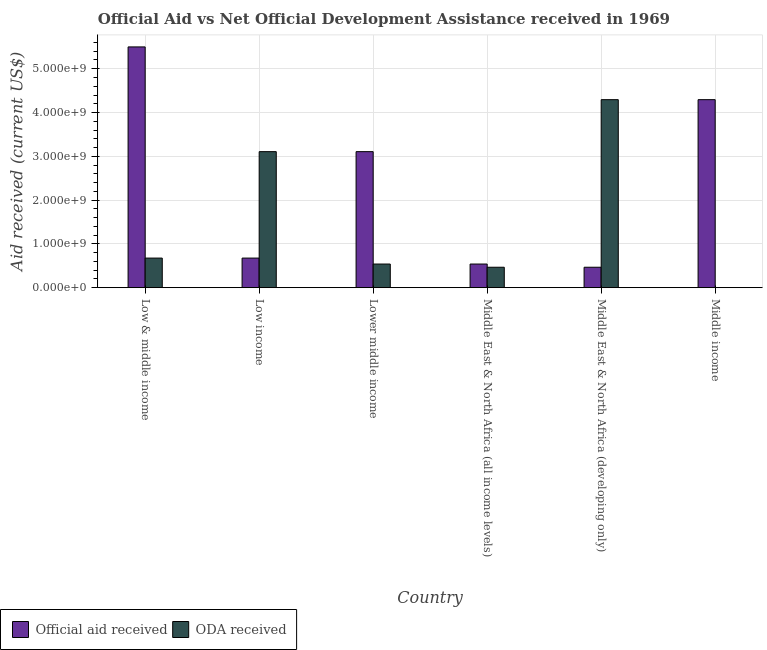In how many cases, is the number of bars for a given country not equal to the number of legend labels?
Ensure brevity in your answer.  0. What is the official aid received in Lower middle income?
Provide a succinct answer. 3.11e+09. Across all countries, what is the maximum oda received?
Your answer should be very brief. 4.29e+09. Across all countries, what is the minimum oda received?
Your answer should be compact. 10000. In which country was the official aid received maximum?
Provide a short and direct response. Low & middle income. In which country was the official aid received minimum?
Your answer should be very brief. Middle East & North Africa (developing only). What is the total official aid received in the graph?
Your answer should be compact. 1.46e+1. What is the difference between the oda received in Low income and that in Middle income?
Give a very brief answer. 3.11e+09. What is the difference between the official aid received in Low income and the oda received in Middle East & North Africa (all income levels)?
Keep it short and to the point. 2.09e+08. What is the average oda received per country?
Offer a terse response. 1.51e+09. What is the difference between the oda received and official aid received in Low & middle income?
Provide a succinct answer. -4.82e+09. What is the ratio of the official aid received in Low & middle income to that in Middle East & North Africa (developing only)?
Give a very brief answer. 11.79. Is the difference between the official aid received in Low income and Middle East & North Africa (developing only) greater than the difference between the oda received in Low income and Middle East & North Africa (developing only)?
Give a very brief answer. Yes. What is the difference between the highest and the second highest official aid received?
Give a very brief answer. 1.20e+09. What is the difference between the highest and the lowest official aid received?
Offer a very short reply. 5.03e+09. Is the sum of the official aid received in Low & middle income and Middle East & North Africa (developing only) greater than the maximum oda received across all countries?
Give a very brief answer. Yes. What does the 2nd bar from the left in Low income represents?
Your response must be concise. ODA received. What does the 2nd bar from the right in Low & middle income represents?
Your answer should be compact. Official aid received. Are all the bars in the graph horizontal?
Ensure brevity in your answer.  No. How many countries are there in the graph?
Keep it short and to the point. 6. What is the difference between two consecutive major ticks on the Y-axis?
Give a very brief answer. 1.00e+09. Does the graph contain any zero values?
Your response must be concise. No. Does the graph contain grids?
Offer a terse response. Yes. How many legend labels are there?
Give a very brief answer. 2. What is the title of the graph?
Offer a very short reply. Official Aid vs Net Official Development Assistance received in 1969 . What is the label or title of the X-axis?
Offer a very short reply. Country. What is the label or title of the Y-axis?
Keep it short and to the point. Aid received (current US$). What is the Aid received (current US$) of Official aid received in Low & middle income?
Offer a terse response. 5.50e+09. What is the Aid received (current US$) in ODA received in Low & middle income?
Provide a short and direct response. 6.76e+08. What is the Aid received (current US$) of Official aid received in Low income?
Give a very brief answer. 6.76e+08. What is the Aid received (current US$) of ODA received in Low income?
Offer a very short reply. 3.11e+09. What is the Aid received (current US$) of Official aid received in Lower middle income?
Your answer should be compact. 3.11e+09. What is the Aid received (current US$) of ODA received in Lower middle income?
Give a very brief answer. 5.39e+08. What is the Aid received (current US$) in Official aid received in Middle East & North Africa (all income levels)?
Your answer should be very brief. 5.39e+08. What is the Aid received (current US$) of ODA received in Middle East & North Africa (all income levels)?
Give a very brief answer. 4.66e+08. What is the Aid received (current US$) of Official aid received in Middle East & North Africa (developing only)?
Your answer should be very brief. 4.66e+08. What is the Aid received (current US$) of ODA received in Middle East & North Africa (developing only)?
Offer a very short reply. 4.29e+09. What is the Aid received (current US$) in Official aid received in Middle income?
Your response must be concise. 4.29e+09. What is the Aid received (current US$) of ODA received in Middle income?
Provide a short and direct response. 10000. Across all countries, what is the maximum Aid received (current US$) of Official aid received?
Keep it short and to the point. 5.50e+09. Across all countries, what is the maximum Aid received (current US$) in ODA received?
Provide a short and direct response. 4.29e+09. Across all countries, what is the minimum Aid received (current US$) of Official aid received?
Provide a succinct answer. 4.66e+08. Across all countries, what is the minimum Aid received (current US$) in ODA received?
Ensure brevity in your answer.  10000. What is the total Aid received (current US$) in Official aid received in the graph?
Keep it short and to the point. 1.46e+1. What is the total Aid received (current US$) of ODA received in the graph?
Your answer should be compact. 9.08e+09. What is the difference between the Aid received (current US$) of Official aid received in Low & middle income and that in Low income?
Your answer should be compact. 4.82e+09. What is the difference between the Aid received (current US$) in ODA received in Low & middle income and that in Low income?
Provide a succinct answer. -2.43e+09. What is the difference between the Aid received (current US$) in Official aid received in Low & middle income and that in Lower middle income?
Make the answer very short. 2.39e+09. What is the difference between the Aid received (current US$) in ODA received in Low & middle income and that in Lower middle income?
Your answer should be compact. 1.36e+08. What is the difference between the Aid received (current US$) in Official aid received in Low & middle income and that in Middle East & North Africa (all income levels)?
Your answer should be compact. 4.96e+09. What is the difference between the Aid received (current US$) of ODA received in Low & middle income and that in Middle East & North Africa (all income levels)?
Keep it short and to the point. 2.09e+08. What is the difference between the Aid received (current US$) of Official aid received in Low & middle income and that in Middle East & North Africa (developing only)?
Your response must be concise. 5.03e+09. What is the difference between the Aid received (current US$) in ODA received in Low & middle income and that in Middle East & North Africa (developing only)?
Your answer should be compact. -3.62e+09. What is the difference between the Aid received (current US$) in Official aid received in Low & middle income and that in Middle income?
Your answer should be compact. 1.20e+09. What is the difference between the Aid received (current US$) of ODA received in Low & middle income and that in Middle income?
Offer a terse response. 6.76e+08. What is the difference between the Aid received (current US$) of Official aid received in Low income and that in Lower middle income?
Make the answer very short. -2.43e+09. What is the difference between the Aid received (current US$) in ODA received in Low income and that in Lower middle income?
Make the answer very short. 2.57e+09. What is the difference between the Aid received (current US$) in Official aid received in Low income and that in Middle East & North Africa (all income levels)?
Ensure brevity in your answer.  1.36e+08. What is the difference between the Aid received (current US$) in ODA received in Low income and that in Middle East & North Africa (all income levels)?
Provide a succinct answer. 2.64e+09. What is the difference between the Aid received (current US$) in Official aid received in Low income and that in Middle East & North Africa (developing only)?
Your answer should be very brief. 2.09e+08. What is the difference between the Aid received (current US$) of ODA received in Low income and that in Middle East & North Africa (developing only)?
Give a very brief answer. -1.19e+09. What is the difference between the Aid received (current US$) of Official aid received in Low income and that in Middle income?
Your answer should be compact. -3.62e+09. What is the difference between the Aid received (current US$) of ODA received in Low income and that in Middle income?
Offer a terse response. 3.11e+09. What is the difference between the Aid received (current US$) of Official aid received in Lower middle income and that in Middle East & North Africa (all income levels)?
Provide a short and direct response. 2.57e+09. What is the difference between the Aid received (current US$) in ODA received in Lower middle income and that in Middle East & North Africa (all income levels)?
Make the answer very short. 7.30e+07. What is the difference between the Aid received (current US$) in Official aid received in Lower middle income and that in Middle East & North Africa (developing only)?
Offer a very short reply. 2.64e+09. What is the difference between the Aid received (current US$) in ODA received in Lower middle income and that in Middle East & North Africa (developing only)?
Make the answer very short. -3.75e+09. What is the difference between the Aid received (current US$) in Official aid received in Lower middle income and that in Middle income?
Provide a succinct answer. -1.19e+09. What is the difference between the Aid received (current US$) in ODA received in Lower middle income and that in Middle income?
Your answer should be very brief. 5.39e+08. What is the difference between the Aid received (current US$) in Official aid received in Middle East & North Africa (all income levels) and that in Middle East & North Africa (developing only)?
Offer a terse response. 7.30e+07. What is the difference between the Aid received (current US$) in ODA received in Middle East & North Africa (all income levels) and that in Middle East & North Africa (developing only)?
Keep it short and to the point. -3.83e+09. What is the difference between the Aid received (current US$) in Official aid received in Middle East & North Africa (all income levels) and that in Middle income?
Offer a terse response. -3.75e+09. What is the difference between the Aid received (current US$) of ODA received in Middle East & North Africa (all income levels) and that in Middle income?
Provide a short and direct response. 4.66e+08. What is the difference between the Aid received (current US$) of Official aid received in Middle East & North Africa (developing only) and that in Middle income?
Offer a very short reply. -3.83e+09. What is the difference between the Aid received (current US$) of ODA received in Middle East & North Africa (developing only) and that in Middle income?
Ensure brevity in your answer.  4.29e+09. What is the difference between the Aid received (current US$) of Official aid received in Low & middle income and the Aid received (current US$) of ODA received in Low income?
Ensure brevity in your answer.  2.39e+09. What is the difference between the Aid received (current US$) of Official aid received in Low & middle income and the Aid received (current US$) of ODA received in Lower middle income?
Offer a very short reply. 4.96e+09. What is the difference between the Aid received (current US$) in Official aid received in Low & middle income and the Aid received (current US$) in ODA received in Middle East & North Africa (all income levels)?
Give a very brief answer. 5.03e+09. What is the difference between the Aid received (current US$) in Official aid received in Low & middle income and the Aid received (current US$) in ODA received in Middle East & North Africa (developing only)?
Your answer should be very brief. 1.20e+09. What is the difference between the Aid received (current US$) in Official aid received in Low & middle income and the Aid received (current US$) in ODA received in Middle income?
Offer a terse response. 5.50e+09. What is the difference between the Aid received (current US$) in Official aid received in Low income and the Aid received (current US$) in ODA received in Lower middle income?
Your answer should be very brief. 1.36e+08. What is the difference between the Aid received (current US$) in Official aid received in Low income and the Aid received (current US$) in ODA received in Middle East & North Africa (all income levels)?
Your answer should be very brief. 2.09e+08. What is the difference between the Aid received (current US$) of Official aid received in Low income and the Aid received (current US$) of ODA received in Middle East & North Africa (developing only)?
Ensure brevity in your answer.  -3.62e+09. What is the difference between the Aid received (current US$) in Official aid received in Low income and the Aid received (current US$) in ODA received in Middle income?
Provide a succinct answer. 6.76e+08. What is the difference between the Aid received (current US$) in Official aid received in Lower middle income and the Aid received (current US$) in ODA received in Middle East & North Africa (all income levels)?
Provide a succinct answer. 2.64e+09. What is the difference between the Aid received (current US$) of Official aid received in Lower middle income and the Aid received (current US$) of ODA received in Middle East & North Africa (developing only)?
Keep it short and to the point. -1.19e+09. What is the difference between the Aid received (current US$) of Official aid received in Lower middle income and the Aid received (current US$) of ODA received in Middle income?
Offer a terse response. 3.11e+09. What is the difference between the Aid received (current US$) of Official aid received in Middle East & North Africa (all income levels) and the Aid received (current US$) of ODA received in Middle East & North Africa (developing only)?
Offer a very short reply. -3.75e+09. What is the difference between the Aid received (current US$) of Official aid received in Middle East & North Africa (all income levels) and the Aid received (current US$) of ODA received in Middle income?
Provide a succinct answer. 5.39e+08. What is the difference between the Aid received (current US$) in Official aid received in Middle East & North Africa (developing only) and the Aid received (current US$) in ODA received in Middle income?
Offer a terse response. 4.66e+08. What is the average Aid received (current US$) of Official aid received per country?
Your response must be concise. 2.43e+09. What is the average Aid received (current US$) of ODA received per country?
Make the answer very short. 1.51e+09. What is the difference between the Aid received (current US$) of Official aid received and Aid received (current US$) of ODA received in Low & middle income?
Provide a short and direct response. 4.82e+09. What is the difference between the Aid received (current US$) of Official aid received and Aid received (current US$) of ODA received in Low income?
Keep it short and to the point. -2.43e+09. What is the difference between the Aid received (current US$) of Official aid received and Aid received (current US$) of ODA received in Lower middle income?
Provide a succinct answer. 2.57e+09. What is the difference between the Aid received (current US$) in Official aid received and Aid received (current US$) in ODA received in Middle East & North Africa (all income levels)?
Provide a succinct answer. 7.30e+07. What is the difference between the Aid received (current US$) in Official aid received and Aid received (current US$) in ODA received in Middle East & North Africa (developing only)?
Offer a terse response. -3.83e+09. What is the difference between the Aid received (current US$) in Official aid received and Aid received (current US$) in ODA received in Middle income?
Ensure brevity in your answer.  4.29e+09. What is the ratio of the Aid received (current US$) of Official aid received in Low & middle income to that in Low income?
Provide a succinct answer. 8.14. What is the ratio of the Aid received (current US$) in ODA received in Low & middle income to that in Low income?
Your response must be concise. 0.22. What is the ratio of the Aid received (current US$) in Official aid received in Low & middle income to that in Lower middle income?
Your response must be concise. 1.77. What is the ratio of the Aid received (current US$) of ODA received in Low & middle income to that in Lower middle income?
Offer a terse response. 1.25. What is the ratio of the Aid received (current US$) of Official aid received in Low & middle income to that in Middle East & North Africa (all income levels)?
Provide a succinct answer. 10.19. What is the ratio of the Aid received (current US$) of ODA received in Low & middle income to that in Middle East & North Africa (all income levels)?
Ensure brevity in your answer.  1.45. What is the ratio of the Aid received (current US$) of Official aid received in Low & middle income to that in Middle East & North Africa (developing only)?
Your answer should be compact. 11.79. What is the ratio of the Aid received (current US$) in ODA received in Low & middle income to that in Middle East & North Africa (developing only)?
Provide a short and direct response. 0.16. What is the ratio of the Aid received (current US$) in Official aid received in Low & middle income to that in Middle income?
Your answer should be compact. 1.28. What is the ratio of the Aid received (current US$) in ODA received in Low & middle income to that in Middle income?
Your response must be concise. 6.76e+04. What is the ratio of the Aid received (current US$) of Official aid received in Low income to that in Lower middle income?
Provide a short and direct response. 0.22. What is the ratio of the Aid received (current US$) in ODA received in Low income to that in Lower middle income?
Provide a short and direct response. 5.76. What is the ratio of the Aid received (current US$) in Official aid received in Low income to that in Middle East & North Africa (all income levels)?
Offer a very short reply. 1.25. What is the ratio of the Aid received (current US$) of ODA received in Low income to that in Middle East & North Africa (all income levels)?
Ensure brevity in your answer.  6.66. What is the ratio of the Aid received (current US$) of Official aid received in Low income to that in Middle East & North Africa (developing only)?
Offer a very short reply. 1.45. What is the ratio of the Aid received (current US$) of ODA received in Low income to that in Middle East & North Africa (developing only)?
Make the answer very short. 0.72. What is the ratio of the Aid received (current US$) in Official aid received in Low income to that in Middle income?
Make the answer very short. 0.16. What is the ratio of the Aid received (current US$) in ODA received in Low income to that in Middle income?
Provide a succinct answer. 3.11e+05. What is the ratio of the Aid received (current US$) of Official aid received in Lower middle income to that in Middle East & North Africa (all income levels)?
Offer a terse response. 5.76. What is the ratio of the Aid received (current US$) in ODA received in Lower middle income to that in Middle East & North Africa (all income levels)?
Your response must be concise. 1.16. What is the ratio of the Aid received (current US$) of Official aid received in Lower middle income to that in Middle East & North Africa (developing only)?
Offer a very short reply. 6.66. What is the ratio of the Aid received (current US$) of ODA received in Lower middle income to that in Middle East & North Africa (developing only)?
Provide a short and direct response. 0.13. What is the ratio of the Aid received (current US$) in Official aid received in Lower middle income to that in Middle income?
Your answer should be compact. 0.72. What is the ratio of the Aid received (current US$) in ODA received in Lower middle income to that in Middle income?
Your answer should be compact. 5.39e+04. What is the ratio of the Aid received (current US$) of Official aid received in Middle East & North Africa (all income levels) to that in Middle East & North Africa (developing only)?
Your response must be concise. 1.16. What is the ratio of the Aid received (current US$) of ODA received in Middle East & North Africa (all income levels) to that in Middle East & North Africa (developing only)?
Offer a terse response. 0.11. What is the ratio of the Aid received (current US$) of Official aid received in Middle East & North Africa (all income levels) to that in Middle income?
Provide a succinct answer. 0.13. What is the ratio of the Aid received (current US$) of ODA received in Middle East & North Africa (all income levels) to that in Middle income?
Offer a very short reply. 4.66e+04. What is the ratio of the Aid received (current US$) in Official aid received in Middle East & North Africa (developing only) to that in Middle income?
Your answer should be compact. 0.11. What is the ratio of the Aid received (current US$) in ODA received in Middle East & North Africa (developing only) to that in Middle income?
Your answer should be compact. 4.29e+05. What is the difference between the highest and the second highest Aid received (current US$) in Official aid received?
Ensure brevity in your answer.  1.20e+09. What is the difference between the highest and the second highest Aid received (current US$) in ODA received?
Your answer should be very brief. 1.19e+09. What is the difference between the highest and the lowest Aid received (current US$) in Official aid received?
Your response must be concise. 5.03e+09. What is the difference between the highest and the lowest Aid received (current US$) of ODA received?
Your answer should be very brief. 4.29e+09. 